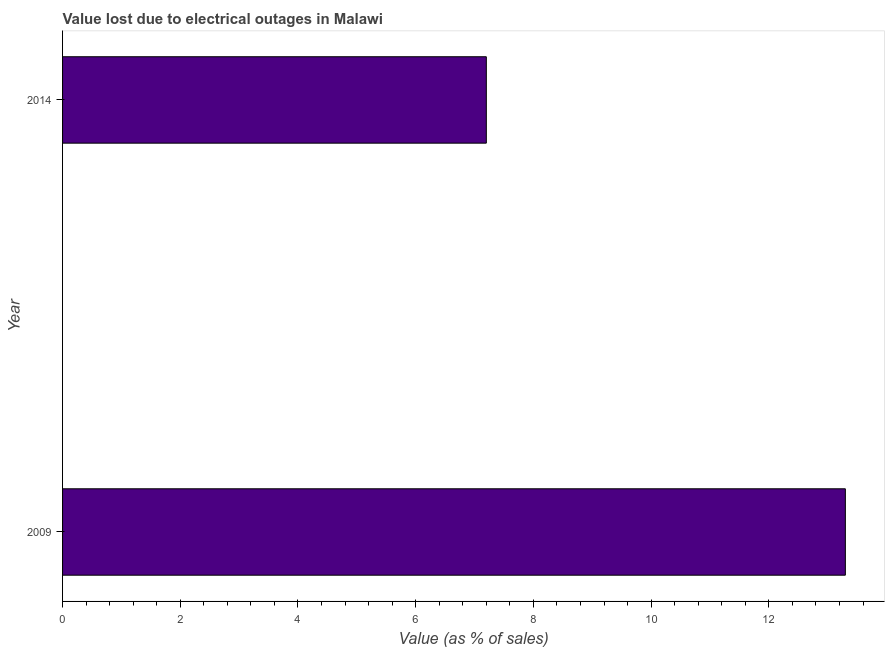What is the title of the graph?
Your answer should be compact. Value lost due to electrical outages in Malawi. What is the label or title of the X-axis?
Make the answer very short. Value (as % of sales). What is the value lost due to electrical outages in 2014?
Offer a very short reply. 7.2. Across all years, what is the maximum value lost due to electrical outages?
Offer a very short reply. 13.3. Across all years, what is the minimum value lost due to electrical outages?
Offer a very short reply. 7.2. What is the average value lost due to electrical outages per year?
Offer a very short reply. 10.25. What is the median value lost due to electrical outages?
Offer a very short reply. 10.25. What is the ratio of the value lost due to electrical outages in 2009 to that in 2014?
Your response must be concise. 1.85. Is the value lost due to electrical outages in 2009 less than that in 2014?
Offer a very short reply. No. How many years are there in the graph?
Ensure brevity in your answer.  2. Are the values on the major ticks of X-axis written in scientific E-notation?
Your answer should be very brief. No. What is the Value (as % of sales) of 2009?
Offer a very short reply. 13.3. What is the difference between the Value (as % of sales) in 2009 and 2014?
Your answer should be very brief. 6.1. What is the ratio of the Value (as % of sales) in 2009 to that in 2014?
Your response must be concise. 1.85. 